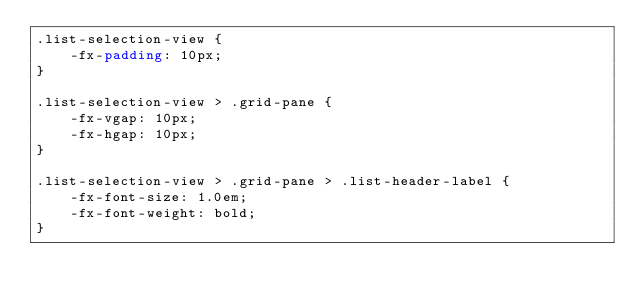Convert code to text. <code><loc_0><loc_0><loc_500><loc_500><_CSS_>.list-selection-view {
	-fx-padding: 10px;	
}

.list-selection-view > .grid-pane {
	-fx-vgap: 10px;
	-fx-hgap: 10px;
}

.list-selection-view > .grid-pane > .list-header-label {
	-fx-font-size: 1.0em;
	-fx-font-weight: bold;
}</code> 